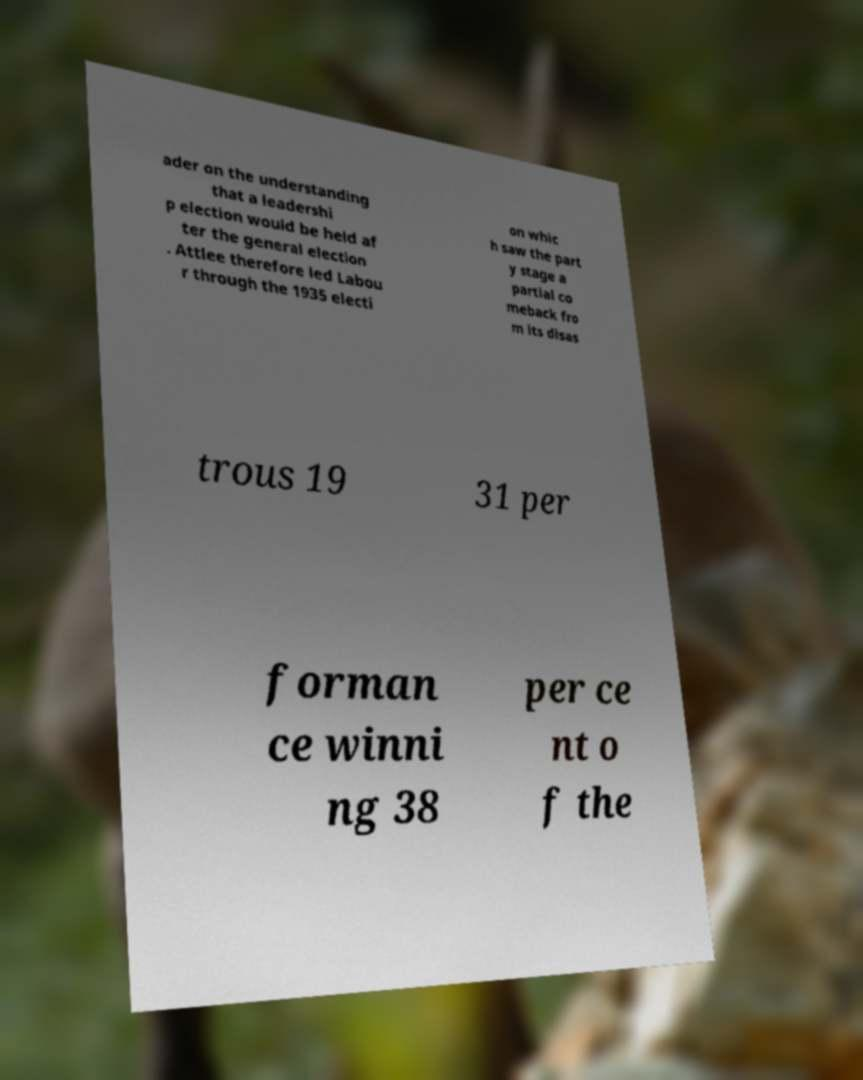Could you assist in decoding the text presented in this image and type it out clearly? ader on the understanding that a leadershi p election would be held af ter the general election . Attlee therefore led Labou r through the 1935 electi on whic h saw the part y stage a partial co meback fro m its disas trous 19 31 per forman ce winni ng 38 per ce nt o f the 